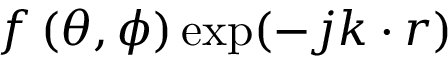<formula> <loc_0><loc_0><loc_500><loc_500>f \left ( \theta , \phi \right ) \exp ( { - j k \cdot r } )</formula> 